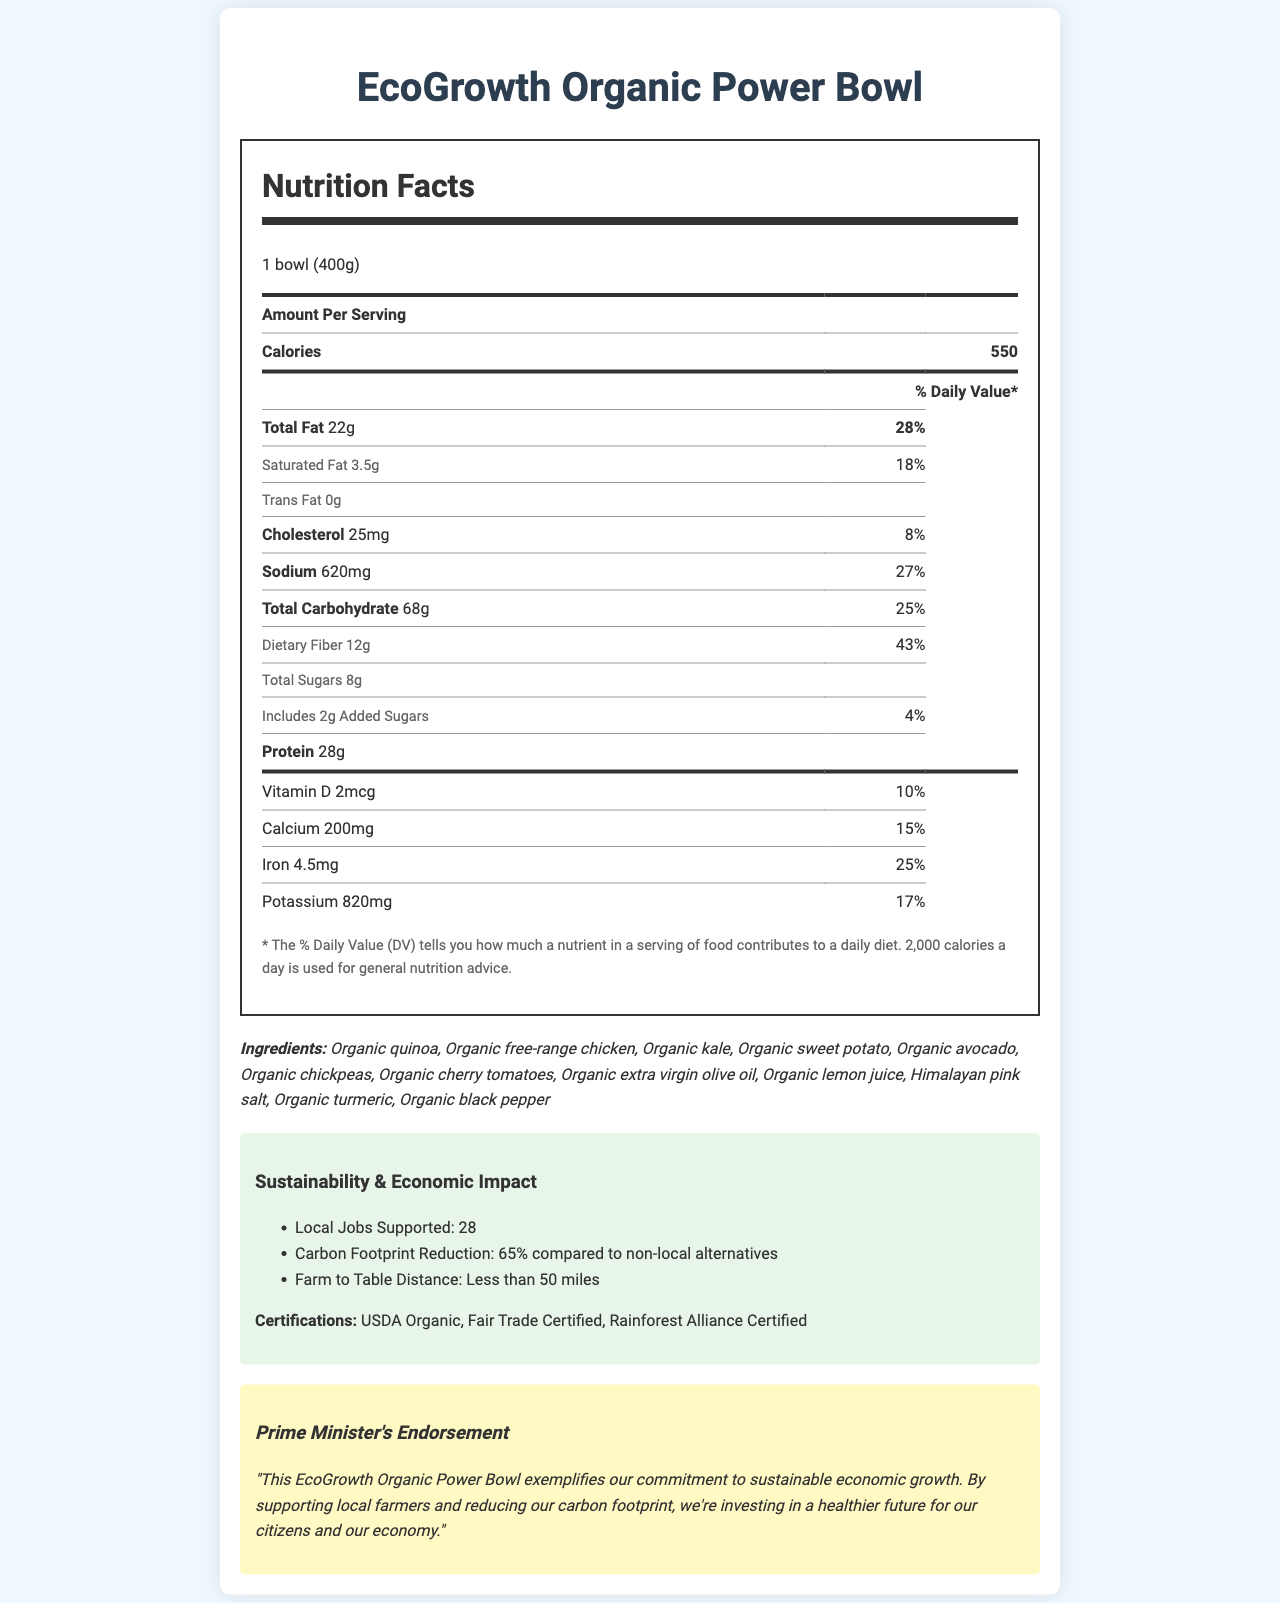what is the serving size of the EcoGrowth Organic Power Bowl? The serving size is clearly mentioned in the nutritional label section of the document as "1 bowl (400g)".
Answer: 1 bowl (400g) how many calories are in one serving of the EcoGrowth Organic Power Bowl? The number of calories is listed under the section "Amount Per Serving" in the document.
Answer: 550 what is the daily value percentage of dietary fiber in the EcoGrowth Organic Power Bowl? The daily value percentage of dietary fiber is mentioned next to its amount under the nutrition facts section.
Answer: 43% what are the main ingredients in the EcoGrowth Organic Power Bowl? The ingredients list is clearly stated under the "Ingredients" section of the document.
Answer: Organic quinoa, Organic free-range chicken, Organic kale, Organic sweet potato, Organic avocado, Organic chickpeas, Organic cherry tomatoes, Organic extra virgin olive oil, Organic lemon juice, Himalayan pink salt, Organic turmeric, Organic black pepper how many jobs does the EcoGrowth Organic Power Bowl support locally? The document specifically mentions that the EcoGrowth Organic Power Bowl supports 28 local jobs under the economic impact section.
Answer: 28 which nutrient has the highest daily value percentage? A. Protein B. Dietary Fiber C. Total Carbohydrate D. Sodium As per the document, dietary fiber has the highest daily value percentage at 43%.
Answer: B what is the farm-to-table distance for the EcoGrowth Organic Power Bowl? A. Less than 100 miles B. Less than 50 miles C. Less than 75 miles D. More than 100 miles The document mentions that the farm-to-table distance is less than 50 miles.
Answer: B does the EcoGrowth Organic Power Bowl contain any allergens? The document lists "None" under the allergens section, indicating that there are no allergens in the product.
Answer: No what is the main idea of this document? The document includes comprehensive details on nutrition facts, ingredients, sustainability impact, and certifications, culminating in a Prime Minister's endorsement about the product's economic and environmental contributions.
Answer: The main idea of this document is to provide detailed nutrition information and sustainability impact for the EcoGrowth Organic Power Bowl. It highlights the organic and locally-sourced nature of the ingredients, the economic support for local jobs, and the environmental benefits, along with an endorsement from the Prime Minister. how many grams of total sugars are in one serving? The amount of total sugars is specified in the nutrition facts section under "Total Sugars".
Answer: 8g how much sodium is in one serving of the EcoGrowth Organic Power Bowl? The sodium content is listed under the nutrition facts section in the document.
Answer: 620mg what certifications does the EcoGrowth Organic Power Bowl hold? These certifications are listed in the sustainability section of the document.
Answer: USDA Organic, Fair Trade Certified, Rainforest Alliance Certified what is the carbon footprint reduction percentage of the EcoGrowth Organic Power Bowl compared to non-local alternatives? The document mentions a 65% reduction in the carbon footprint under the economic impact section.
Answer: 65% who endorses the EcoGrowth Organic Power Bowl for its economic and sustainability impact? The endorsement is clearly stated in the last section of the document labeled "Prime Minister's Endorsement".
Answer: The Prime Minister how many grams of protein does the EcoGrowth Organic Power Bowl have per serving? The protein content is listed under the nutrition facts section in the document.
Answer: 28g does the document provide the exact amount of potassium in the EcoGrowth Organic Power Bowl? The exact amount of potassium is 820mg, as stated under the nutrition facts section.
Answer: Yes is the EcoGrowth Organic Power Bowl gluten-free? The document does not specify whether the EcoGrowth Organic Power Bowl is gluten-free.
Answer: Cannot be determined 